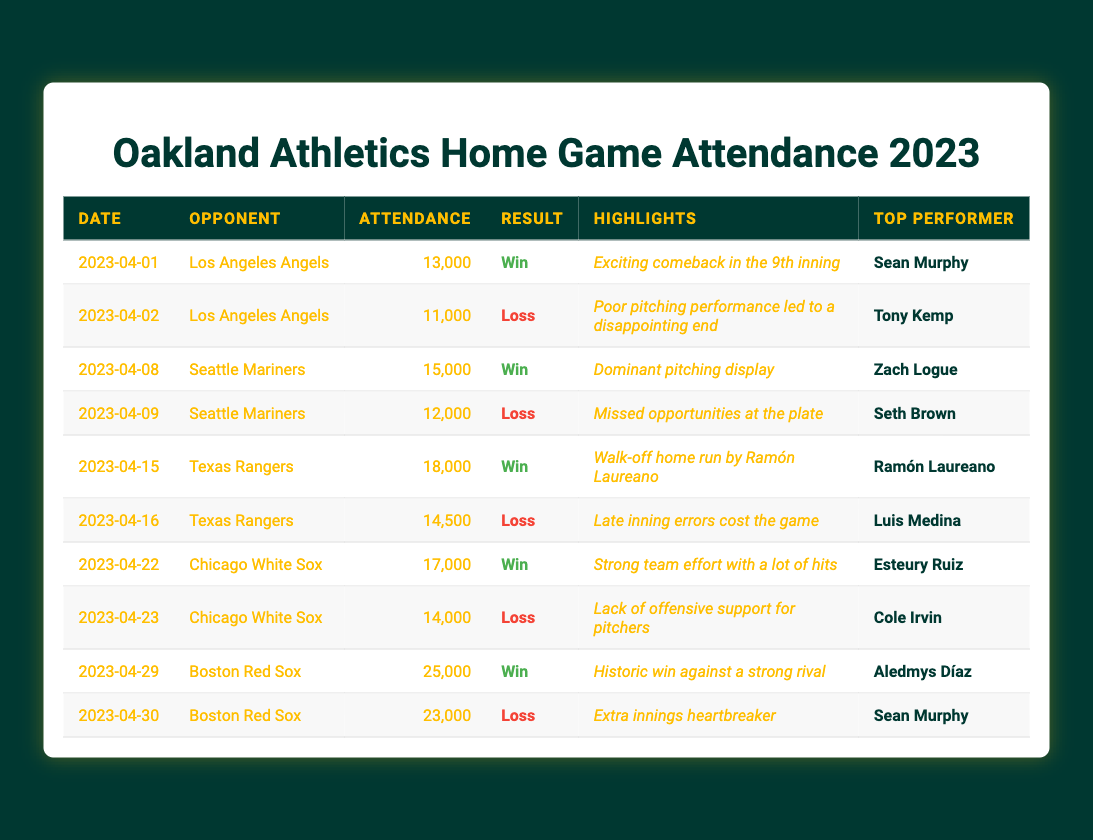What was the highest attendance recorded at a home game in 2023? The table shows attendance figures for each game. Scanning through the attendance column, the highest number is 25,000, which occurred on April 29 against the Boston Red Sox.
Answer: 25,000 How many games did the Oakland Athletics win in April 2023? Counting the "Win" results in the table, there are six games listed as wins during April.
Answer: 6 What was the average attendance for the games that the Athletics lost in April? The lost games had attendances of 11,000, 12,000, 14,500, 14,000, 23,000. Adding these gives 11,000 + 12,000 + 14,500 + 14,000 + 23,000 = 74,500. There are 5 losses, so the average is 74,500 / 5 = 14,900.
Answer: 14,900 Which opponent had the highest attendance recorded against the Athletics? Reviewing the attendance figures per opponent, the Boston Red Sox on April 29 had the highest attendance at 25,000.
Answer: Boston Red Sox Did the Athletics have more wins or losses in April 2023? There were six wins and four losses in April, indicating more wins than losses.
Answer: More wins What was the average attendance of all home games played in April? The total attendance for all ten games is 13000 + 11000 + 15000 + 12000 + 18000 + 14500 + 17000 + 14000 + 25000 + 23000 = 123500. Since there are 10 games, the average attendance is 123500 / 10 = 12350.
Answer: 12350 Which game had the most exciting highlights according to the table? The table indicates that the game against the Los Angeles Angels on April 1 had highlights described as an "Exciting comeback in the 9th inning," suggesting it was particularly thrilling.
Answer: April 1 vs Los Angeles Angels How many games did the Athletics score at least 17,000 in attendance? Looking through the attendance data, the games with attendance greater than or equal to 17,000 were on April 22 (17,000) and April 29 (25,000), making a total of three games.
Answer: 3 What can be inferred about the Athletics' performance against their top rival, the Boston Red Sox? The Athletics had split results against the Red Sox, winning one game (with the highest attendance at 25,000) and losing another in extra innings, which indicates that the rivalry is competitive and engaging for fans.
Answer: Competitive rivalry What was the average attendance for games with top performers named Sean Murphy? The games with Sean Murphy were on April 1 (13,000) and April 30 (23,000). Summing them gives 13,000 + 23,000 = 36,000. The average for these two games is 36,000 / 2 = 18,000.
Answer: 18,000 